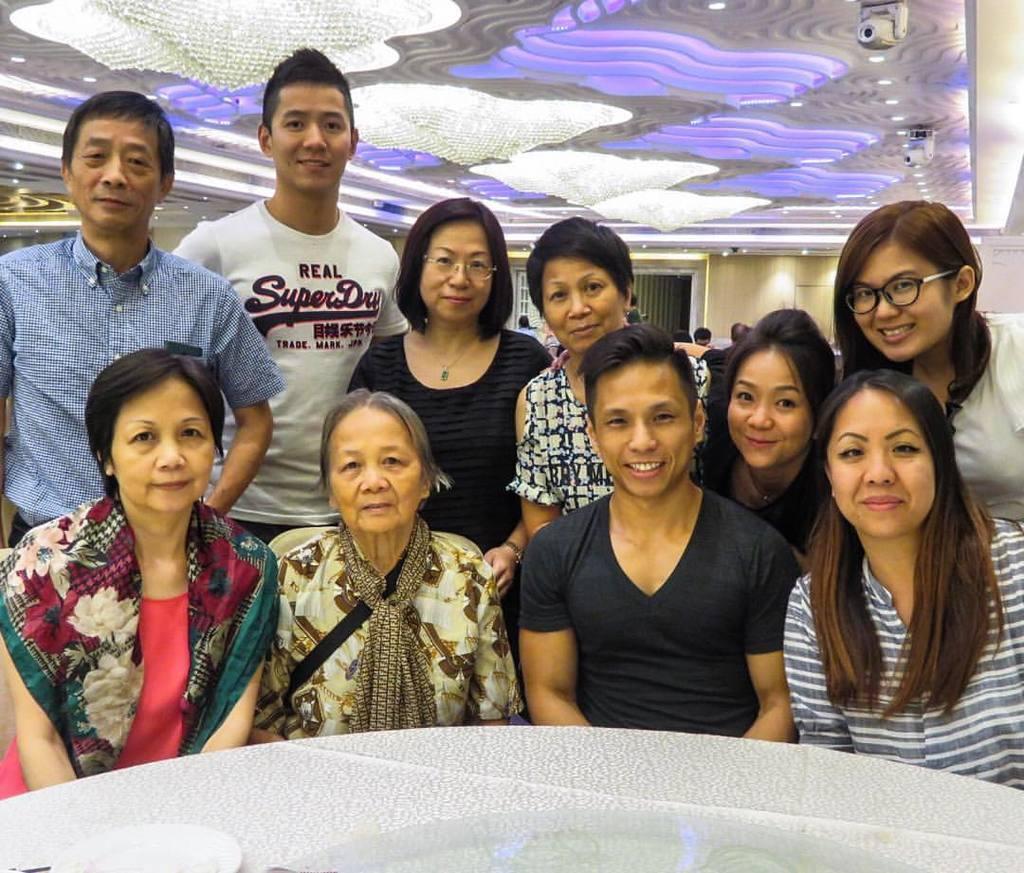How would you summarize this image in a sentence or two? There are people smiling. We can see plate on the table. At the top we can see lights. In the background we can see wall and people. 